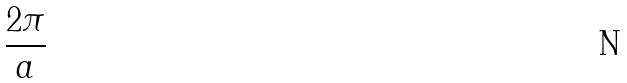Convert formula to latex. <formula><loc_0><loc_0><loc_500><loc_500>\frac { 2 \pi } { a }</formula> 